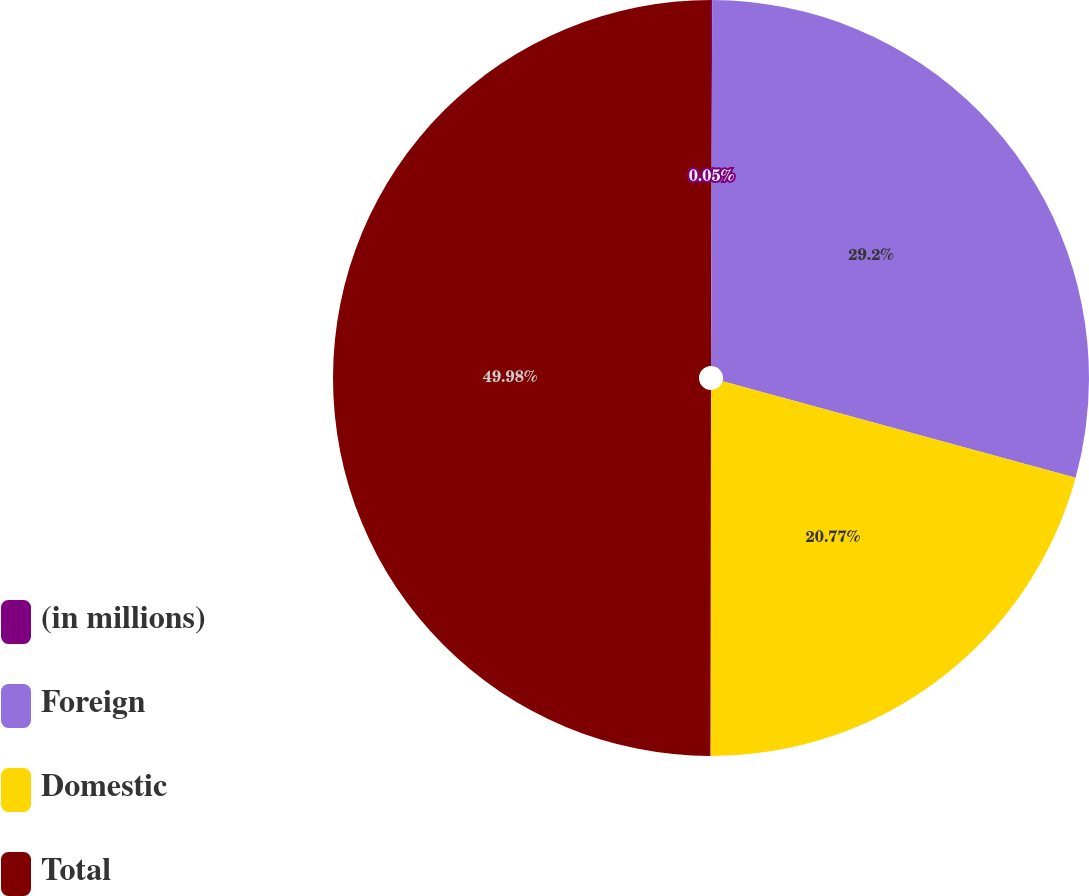Convert chart. <chart><loc_0><loc_0><loc_500><loc_500><pie_chart><fcel>(in millions)<fcel>Foreign<fcel>Domestic<fcel>Total<nl><fcel>0.05%<fcel>29.2%<fcel>20.77%<fcel>49.97%<nl></chart> 